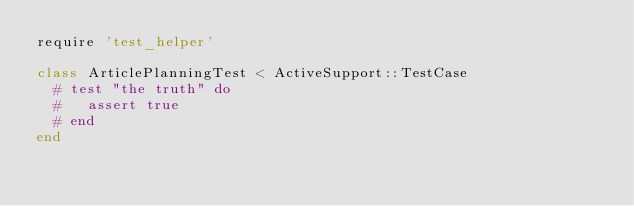Convert code to text. <code><loc_0><loc_0><loc_500><loc_500><_Ruby_>require 'test_helper'

class ArticlePlanningTest < ActiveSupport::TestCase
  # test "the truth" do
  #   assert true
  # end
end
</code> 